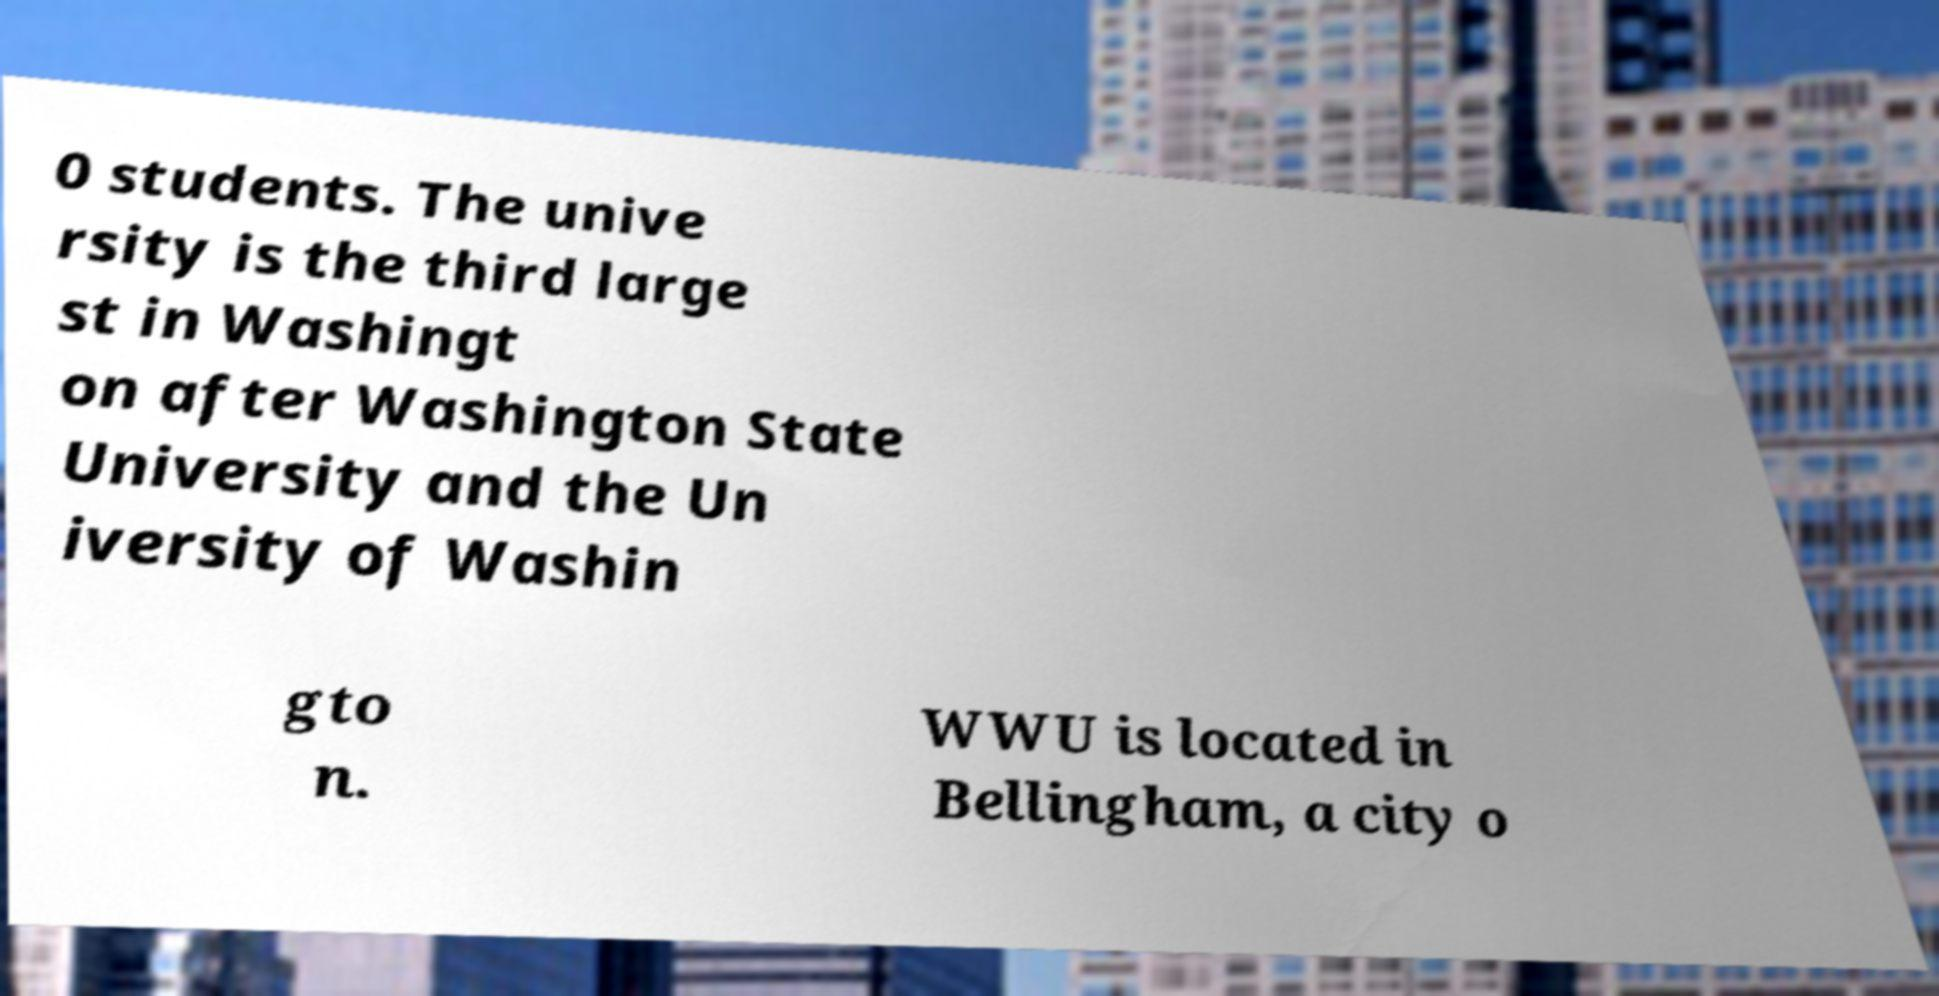Please read and relay the text visible in this image. What does it say? 0 students. The unive rsity is the third large st in Washingt on after Washington State University and the Un iversity of Washin gto n. WWU is located in Bellingham, a city o 